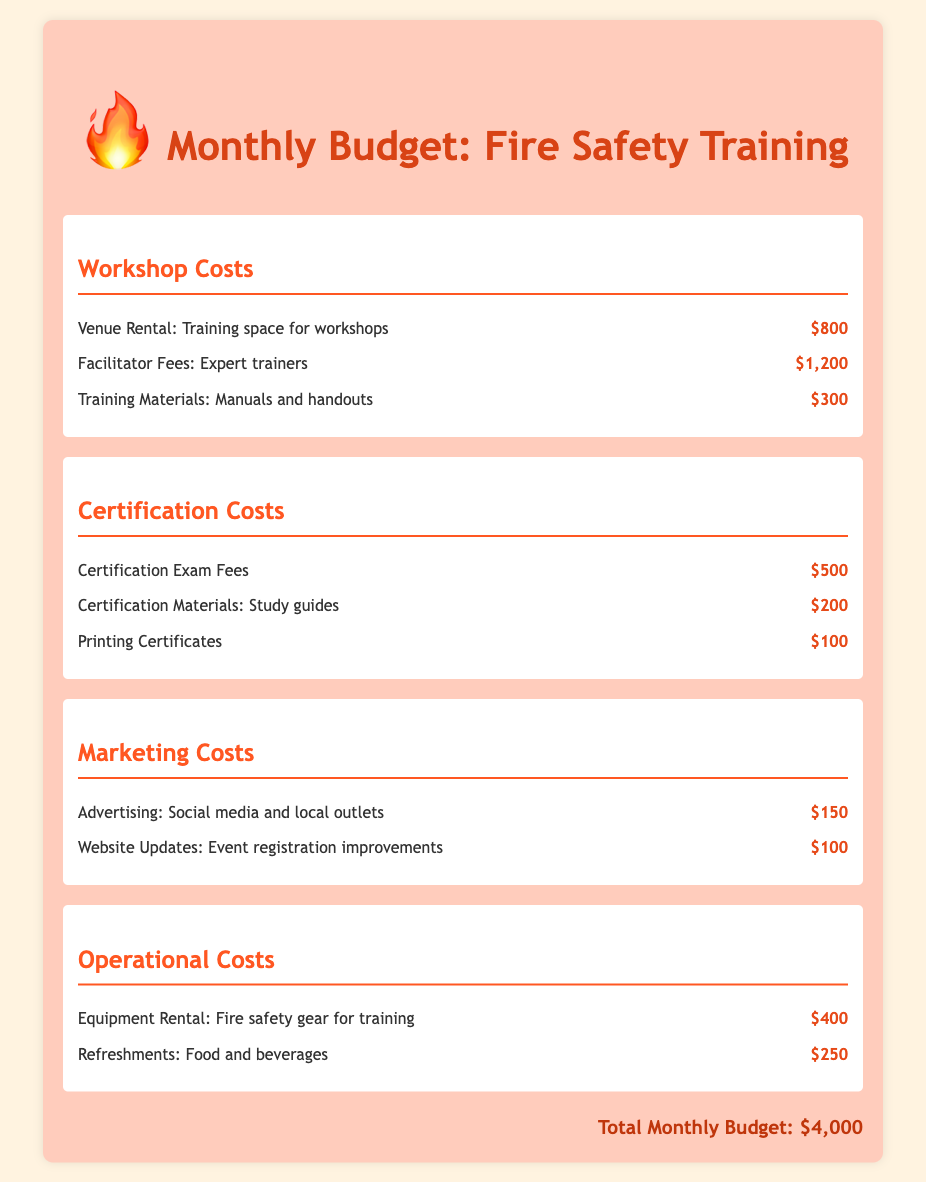What is the total monthly budget? The total monthly budget is presented at the bottom of the document, summarizing all costs.
Answer: $4,000 How much is allocated for facilitator fees? Facilitator fees are listed under workshop costs, indicating the amount dedicated to expert trainers.
Answer: $1,200 What are the certification exam fees? The document specifies the cost of certification exam fees in the certification costs section.
Answer: $500 Which section has the lowest cost item? By examining each section, the costs can be compared, revealing the lowest item in the marketing costs section.
Answer: $100 What is the cost of printing certificates? The printing certificates cost is explicitly stated under the certification costs section.
Answer: $100 What is the total cost for training materials? Training materials can be found in both the workshop costs and certification costs sections, and their total is calculated from those amounts.
Answer: $500 How much is budgeted for equipment rental? Equipment rental fees are detailed in the operational costs, providing a clear amount allocated for this expense.
Answer: $400 Which category includes advertising costs? The marketing costs section details the expenses related to advertising for the training workshops.
Answer: Marketing Costs What costs are associated with refreshments? Refreshment costs can be found under operational costs, indicating the budget for food and beverages.
Answer: $250 